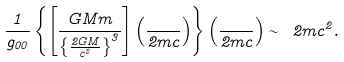Convert formula to latex. <formula><loc_0><loc_0><loc_500><loc_500>\frac { 1 } { g _ { 0 0 } } \left \{ \left [ \frac { G M m } { \left \{ \frac { 2 G M } { c ^ { 2 } } \right \} ^ { 3 } } \right ] \left ( \frac { } { 2 m c } \right ) \right \} \left ( \frac { } { 2 m c } \right ) \sim \ 2 m c ^ { 2 } .</formula> 